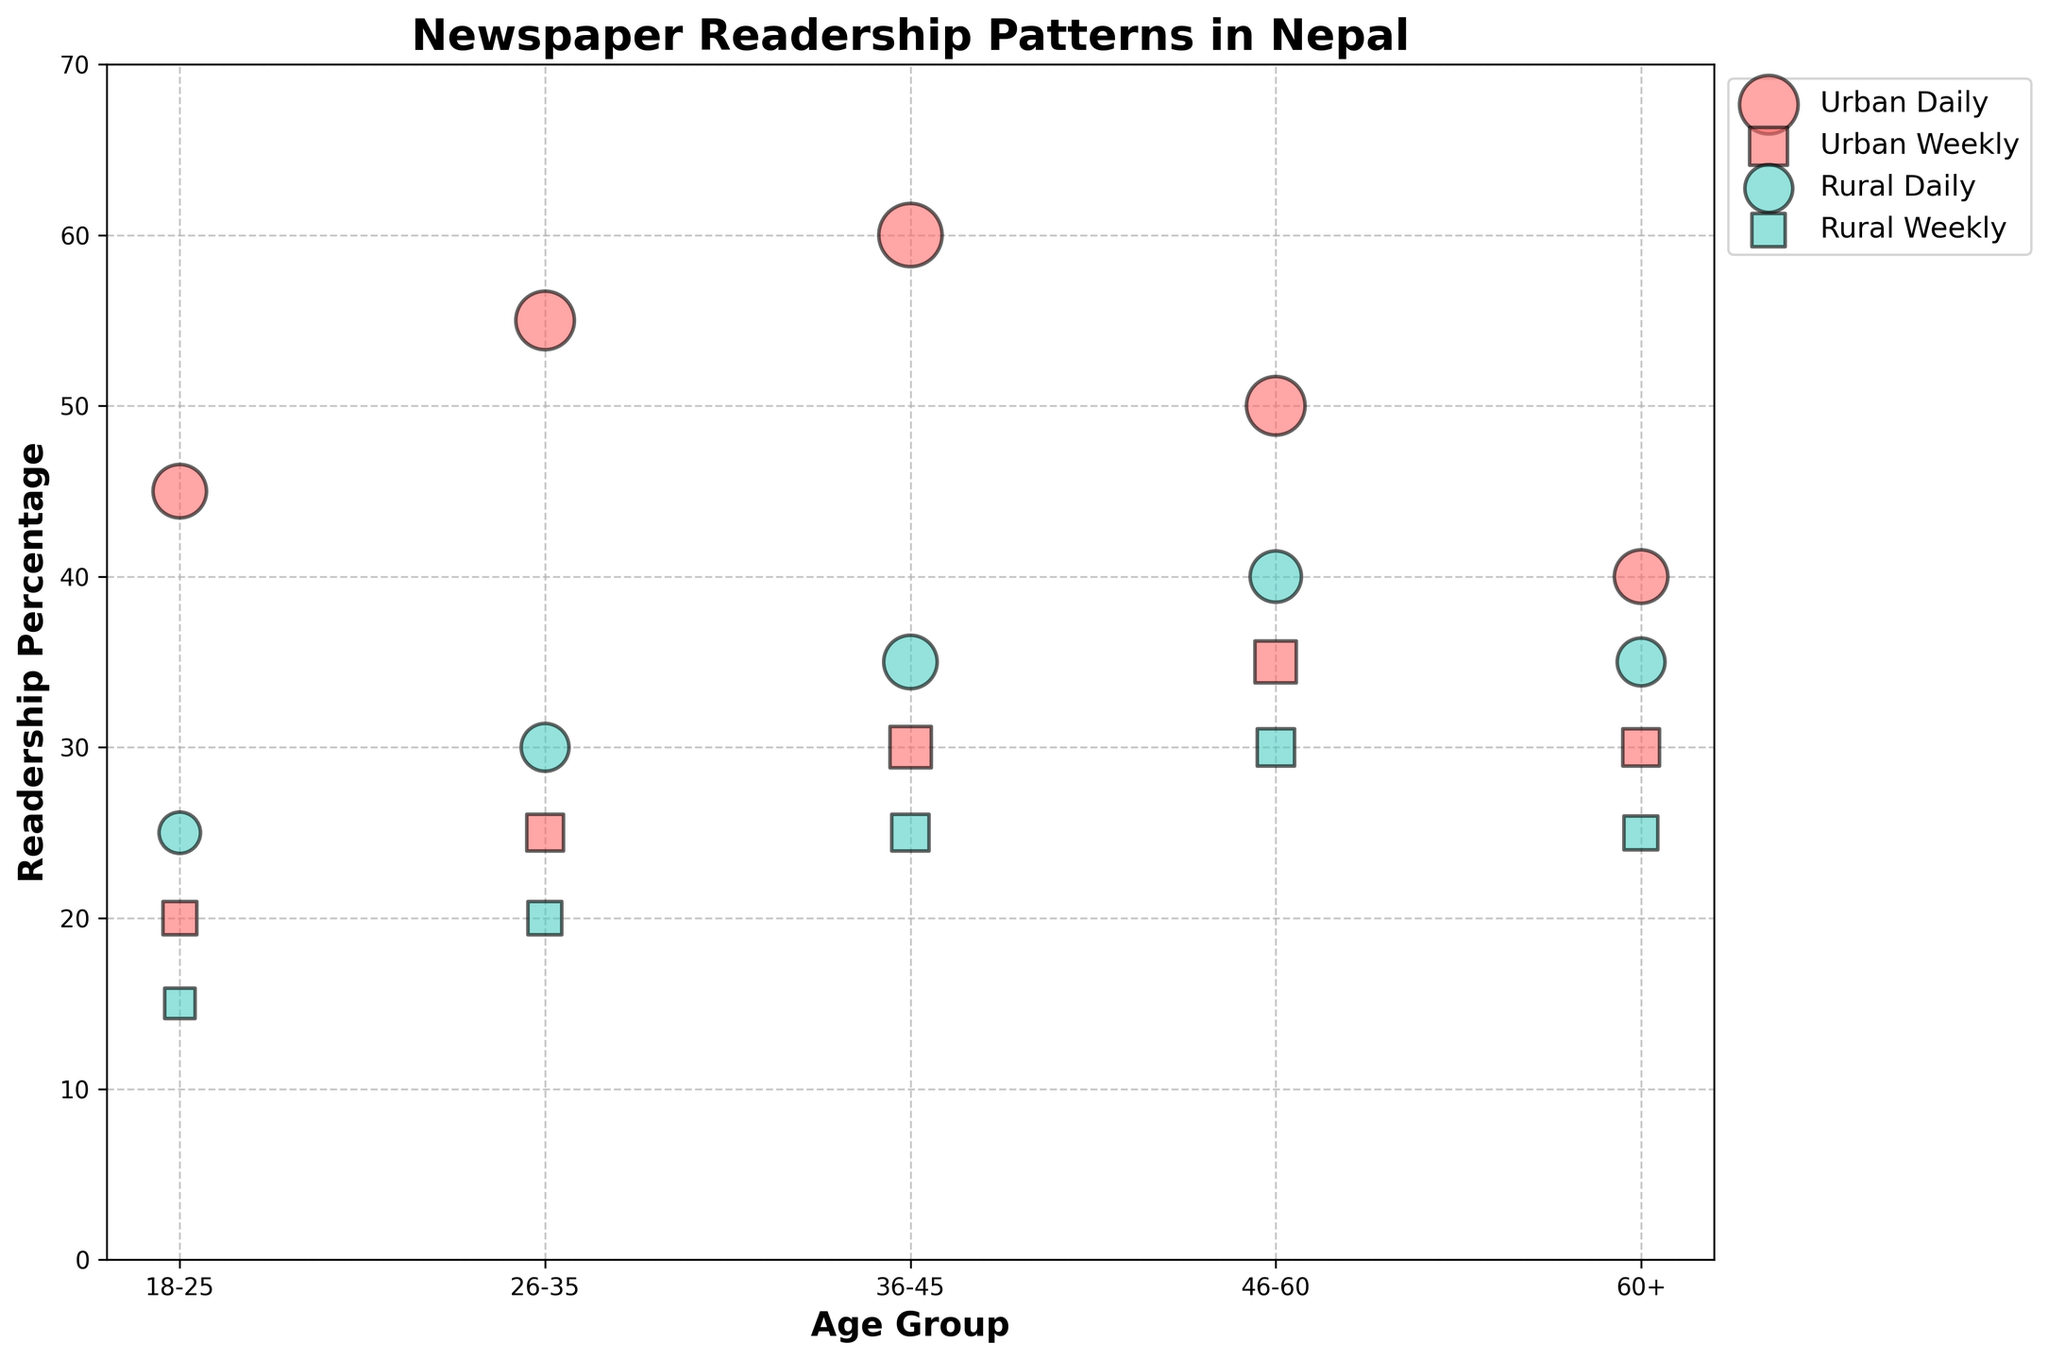What's the title of the figure? The title of the figure is usually displayed at the top. Here, the displayed title is "Newspaper Readership Patterns in Nepal."
Answer: Newspaper Readership Patterns in Nepal What age group has the highest readership percentage for Daily newspapers in Urban areas? By looking at the bubbles corresponding to the 'Daily' and 'Urban' categories, the largest bubble size and highest position on the y-axis is for the 36-45 age group with a readership percentage of 60%.
Answer: 36-45 Which area has the larger bubble size for Weekly newspapers in the 18-25 age group? We need to compare the bubble sizes for Weekly newspapers in Urban and Rural areas for the 18-25 age group. The Urban area has a bubble size of 1.0, while the Rural area has a bubble size of 0.8, making the Urban bubble larger.
Answer: Urban How does the Urban Daily readership percentage change as age increases from 18-25 to 36-45? For Urban Daily newspapers, the readership percentage increases as age goes from 18-25 (45%) to 26-35 (55%) and further to 36-45 (60%).
Answer: Increases What is the difference in readership percentage between Urban Daily and Rural Daily newspapers for the 26-35 age group? To find the difference, look at the Urban Daily (55%) and Rural Daily (30%) percentages for the 26-35 age group. The difference is 55% - 30% = 25%.
Answer: 25% Which newspaper type has a more consistent readership percentage across all age groups in Rural areas? To determine consistency, compare the variability in the readership percentages for Daily and Weekly newspapers in Rural areas across different age groups. Rural Daily fluctuates from 25% to 40%, while Weekly ranges from 15% to 30%, indicating Weekly is more consistent.
Answer: Weekly What is the combined bubble size for Urban and Rural Weekly newspapers in the 36-45 age group? We add the bubble sizes for Urban Weekly (1.5) and Rural Weekly (1.2) to get 1.5 + 1.2 = 2.7.
Answer: 2.7 Among all age groups, which has the highest disparity in readership percentage between Urban Weekly and Rural Weekly newspapers? Looking at each age group, the 46-60 age group shows a 35% Urban Weekly vs. 30% Rural Weekly, with a 5% difference. Other age groups have larger differences: 36-45 has 30% vs. 25% (5%), 26-35 has 25% vs. 20% (5%), and 18-25 has 20% vs. 15% (5%). Determining the highest difference, the result is consistent across these groups, making it 5%.
Answer: All groups have the same disparity (5%) What is the pattern observed in Rural Daily readership percentages as age increases? Examining Rural Daily readership percentages across age groups, there is an increasing trend from 18-25 (25%) to 26-35 (30%) to 36-45 (35%) and a slight increase from 36-45 (35%) to 46-60 (40%), then a decrease to 60+ (35%).
Answer: Increases up to 46-60, then decreases 